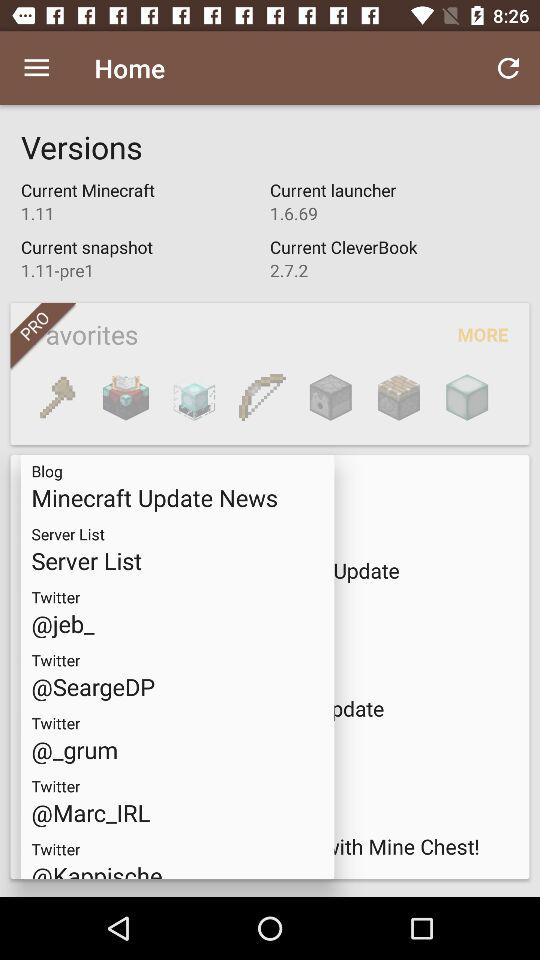Which option makes use of the 2.7.2 version? The option is "Current CleverBook". 